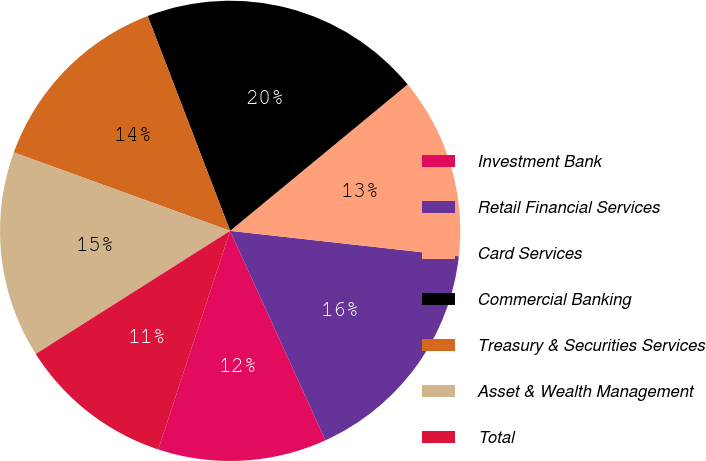Convert chart to OTSL. <chart><loc_0><loc_0><loc_500><loc_500><pie_chart><fcel>Investment Bank<fcel>Retail Financial Services<fcel>Card Services<fcel>Commercial Banking<fcel>Treasury & Securities Services<fcel>Asset & Wealth Management<fcel>Total<nl><fcel>11.85%<fcel>16.44%<fcel>12.74%<fcel>19.86%<fcel>13.63%<fcel>14.52%<fcel>10.96%<nl></chart> 